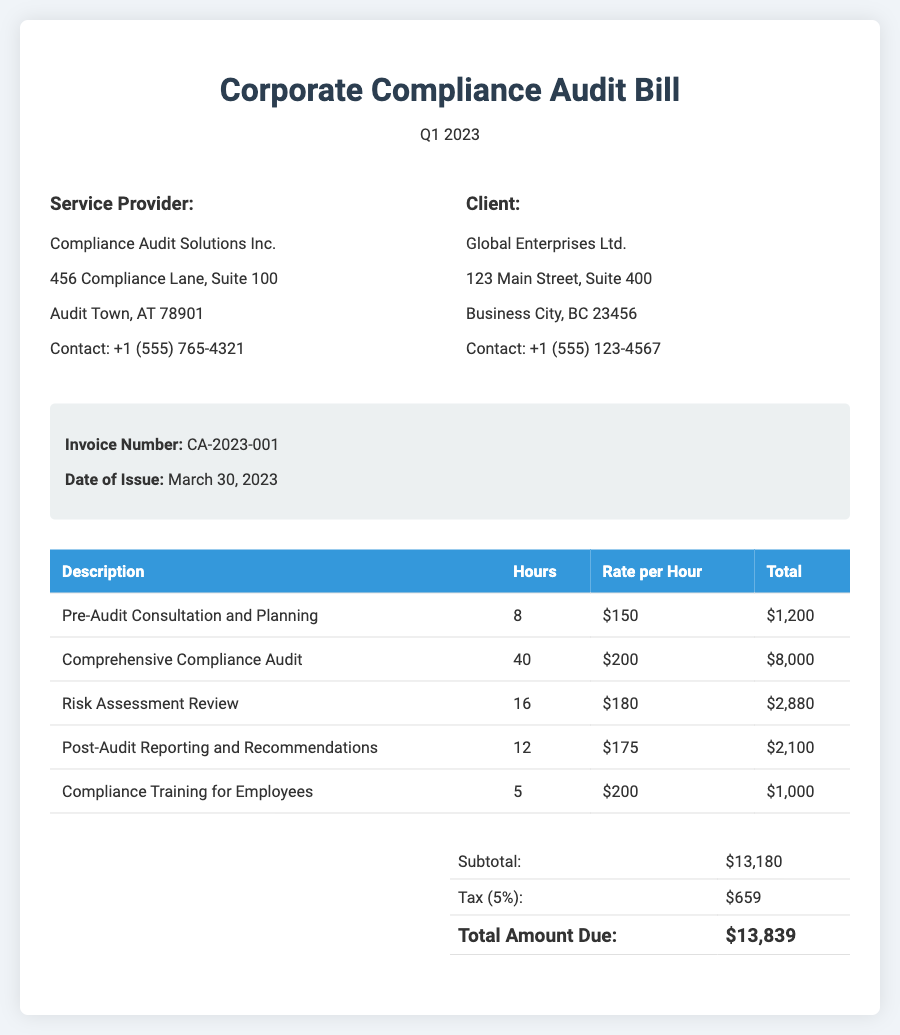What is the invoice number? The invoice number is stated clearly in the document under invoice details.
Answer: CA-2023-001 Who is the service provider? The name of the service provider is mentioned at the top of the company details section.
Answer: Compliance Audit Solutions Inc What is the total amount due? The total amount due can be found in the total section of the document.
Answer: $13,839 How many hours were spent on the comprehensive compliance audit? The number of hours for the comprehensive compliance audit is specified in the table under the hours column.
Answer: 40 What is the tax rate applied in the bill? The tax rate is indicated in the total section of the document.
Answer: 5% What is the total cost for compliance training for employees? The total cost is calculated based on the hours and rate provided in the table.
Answer: $1,000 What service was provided before the audit? The service provided before the audit is listed in the description column of the table.
Answer: Pre-Audit Consultation and Planning How many services are detailed in the bill? The number of services can be determined by counting the rows in the services table.
Answer: 5 What date was the bill issued? The date of issue is found in the invoice details section of the document.
Answer: March 30, 2023 